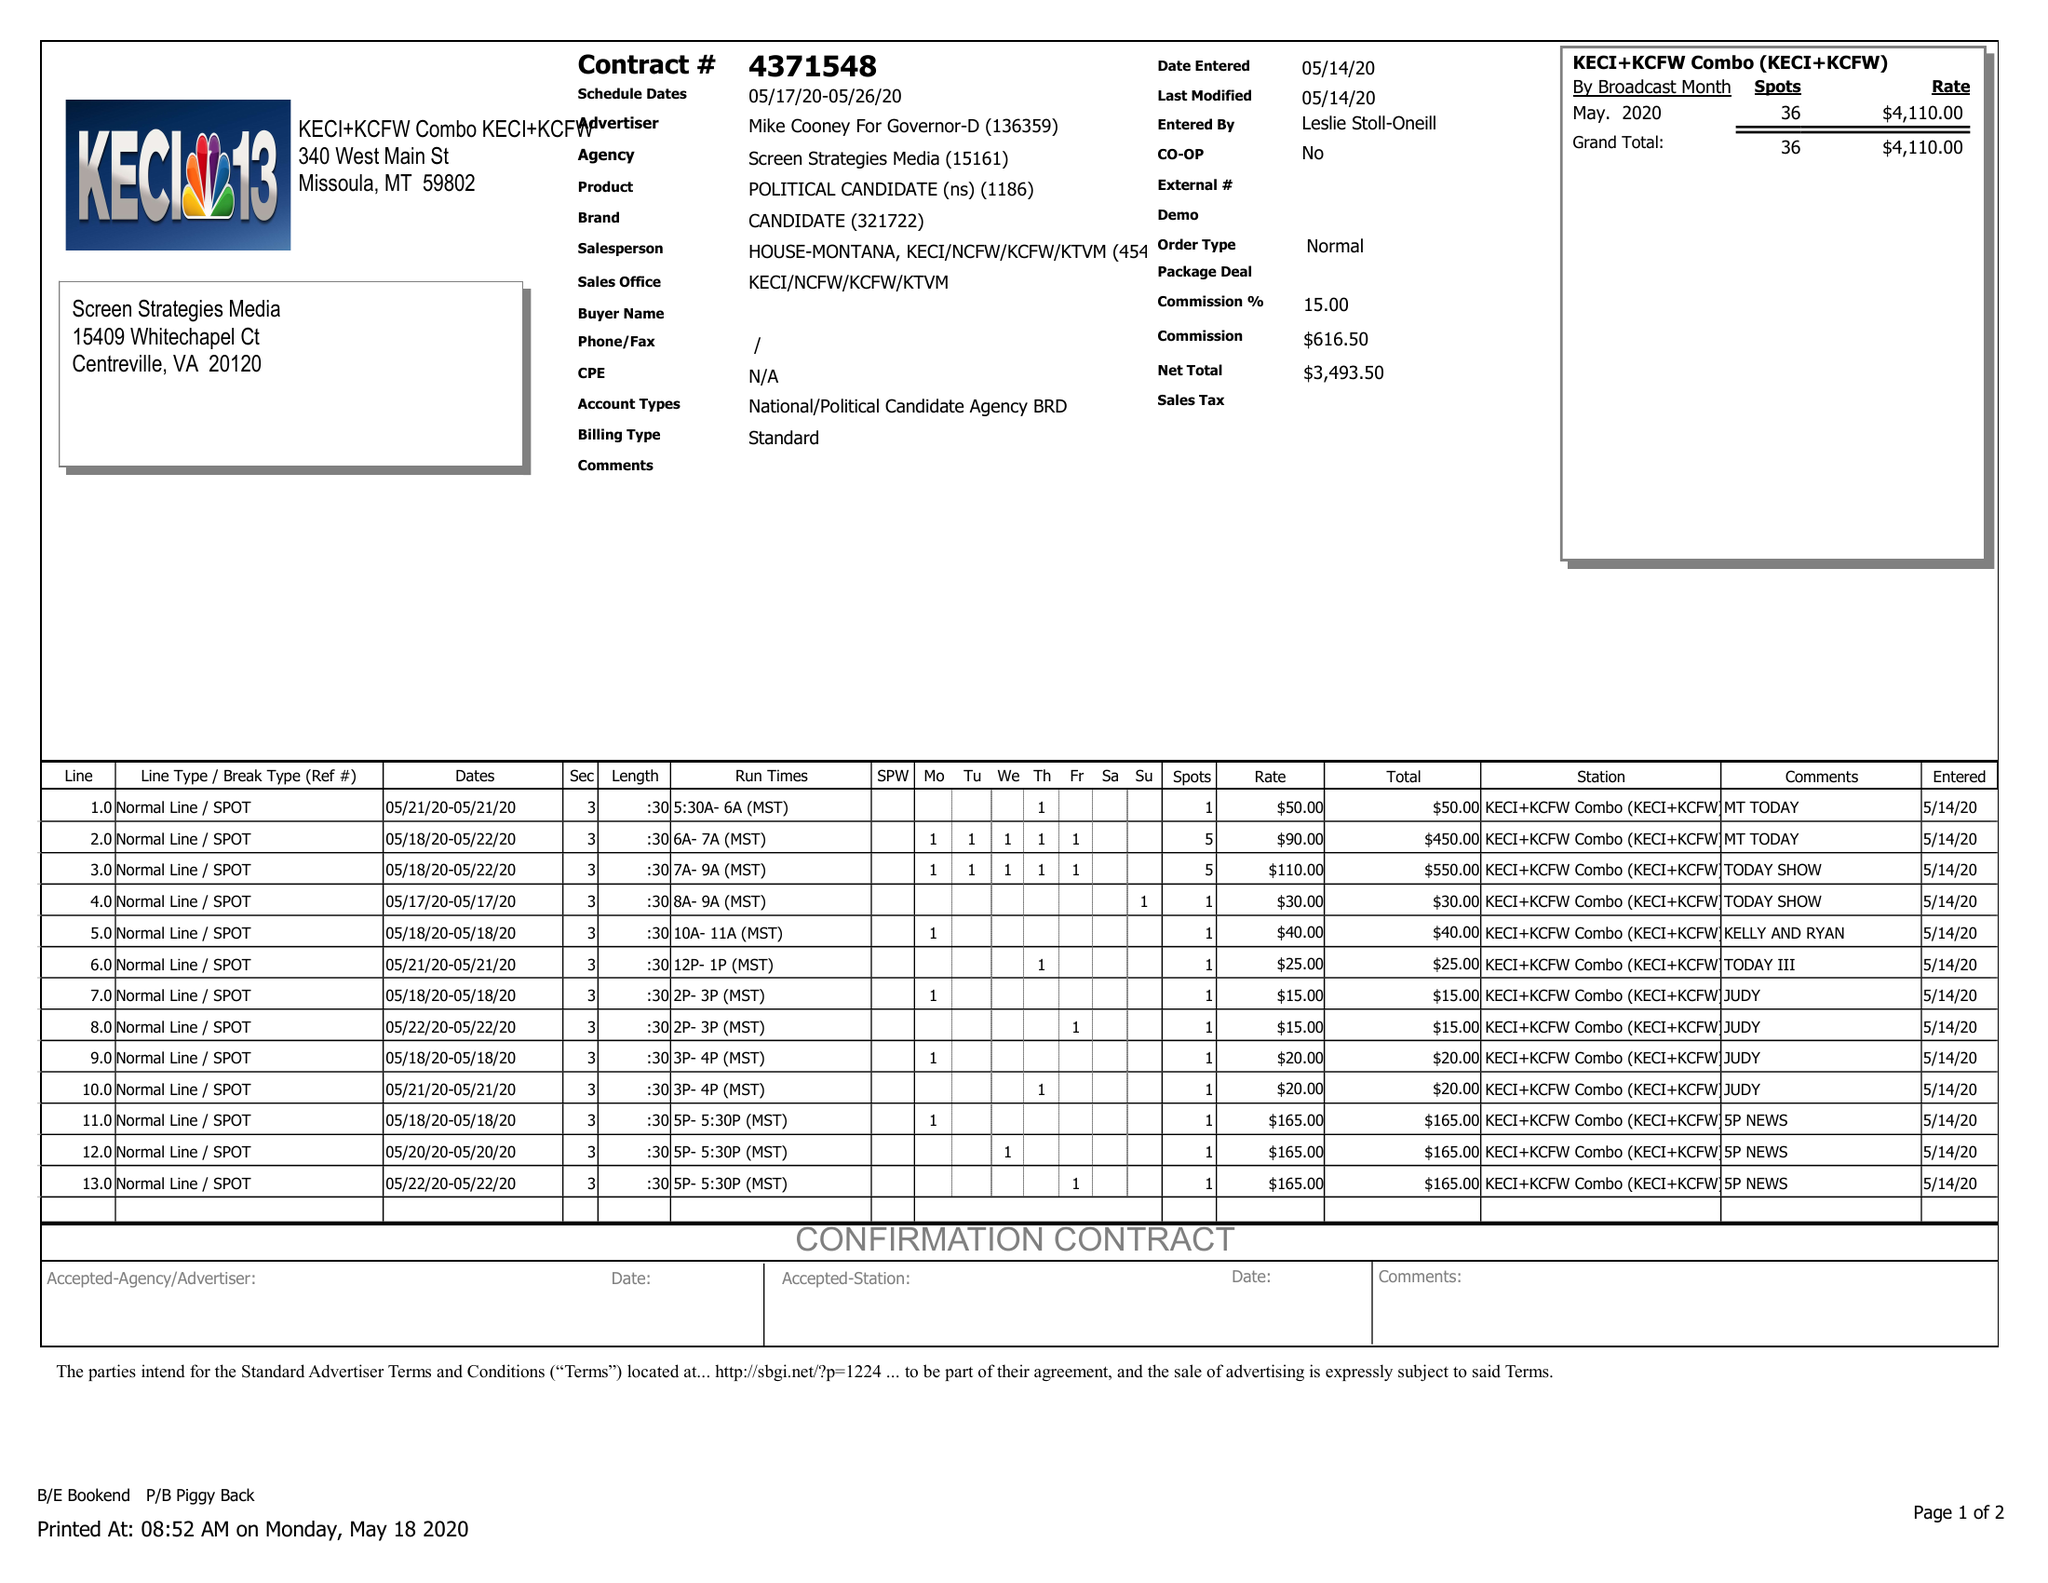What is the value for the advertiser?
Answer the question using a single word or phrase. MIKE COONEY FOR GOVERNOR-D 